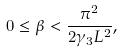<formula> <loc_0><loc_0><loc_500><loc_500>0 \leq \beta < \frac { \pi ^ { 2 } } { 2 \gamma _ { 3 } L ^ { 2 } } ,</formula> 